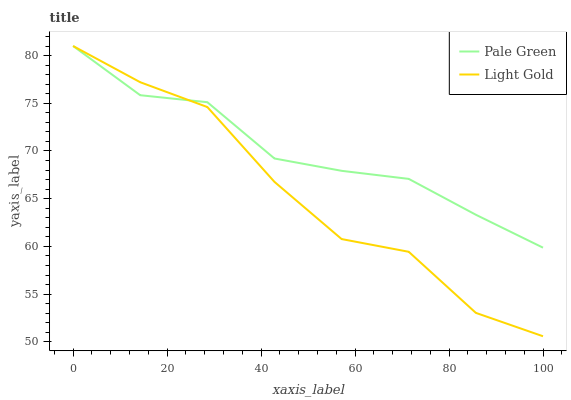Does Light Gold have the minimum area under the curve?
Answer yes or no. Yes. Does Pale Green have the maximum area under the curve?
Answer yes or no. Yes. Does Light Gold have the maximum area under the curve?
Answer yes or no. No. Is Pale Green the smoothest?
Answer yes or no. Yes. Is Light Gold the roughest?
Answer yes or no. Yes. Is Light Gold the smoothest?
Answer yes or no. No. Does Light Gold have the lowest value?
Answer yes or no. Yes. Does Light Gold have the highest value?
Answer yes or no. Yes. Does Light Gold intersect Pale Green?
Answer yes or no. Yes. Is Light Gold less than Pale Green?
Answer yes or no. No. Is Light Gold greater than Pale Green?
Answer yes or no. No. 